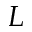Convert formula to latex. <formula><loc_0><loc_0><loc_500><loc_500>L</formula> 